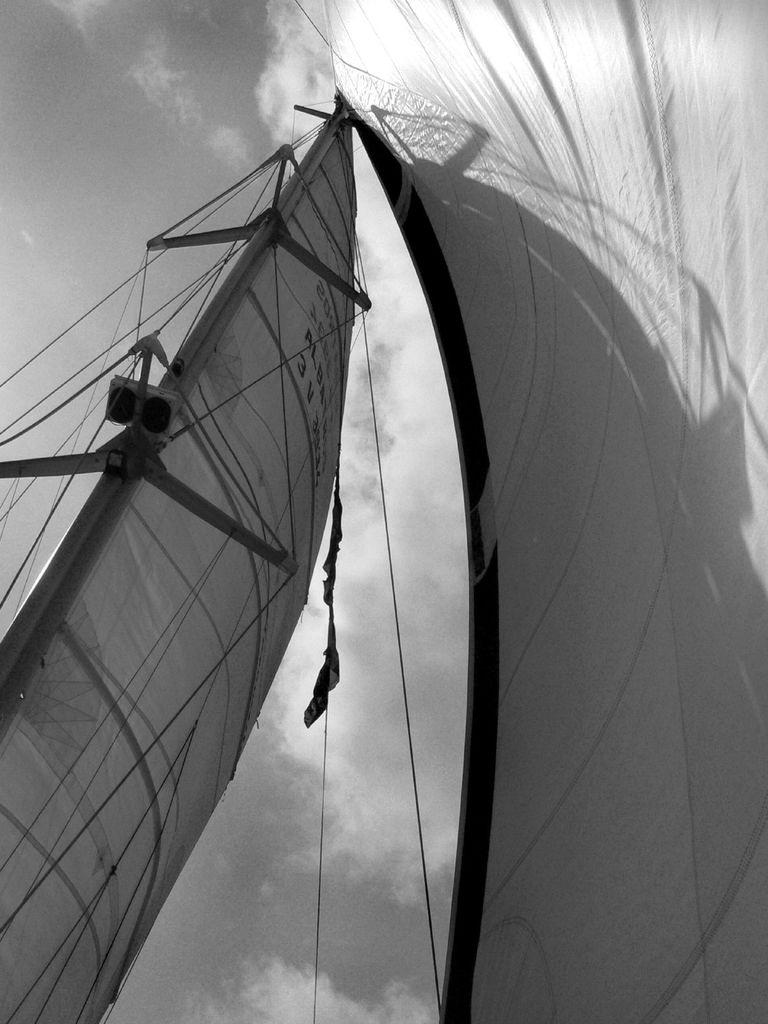What is the color scheme of the image? The picture is in black and white. What can be seen in the image? There is a sailboat in the image. What is visible in the background of the image? The sky is visible in the background of the image. Can you describe the sky in the image? Clouds are present in the sky. How much profit did the uncle make from the sailboat in the image? There is no information about profit or an uncle in the image, as it only features a sailboat and a cloudy sky. 